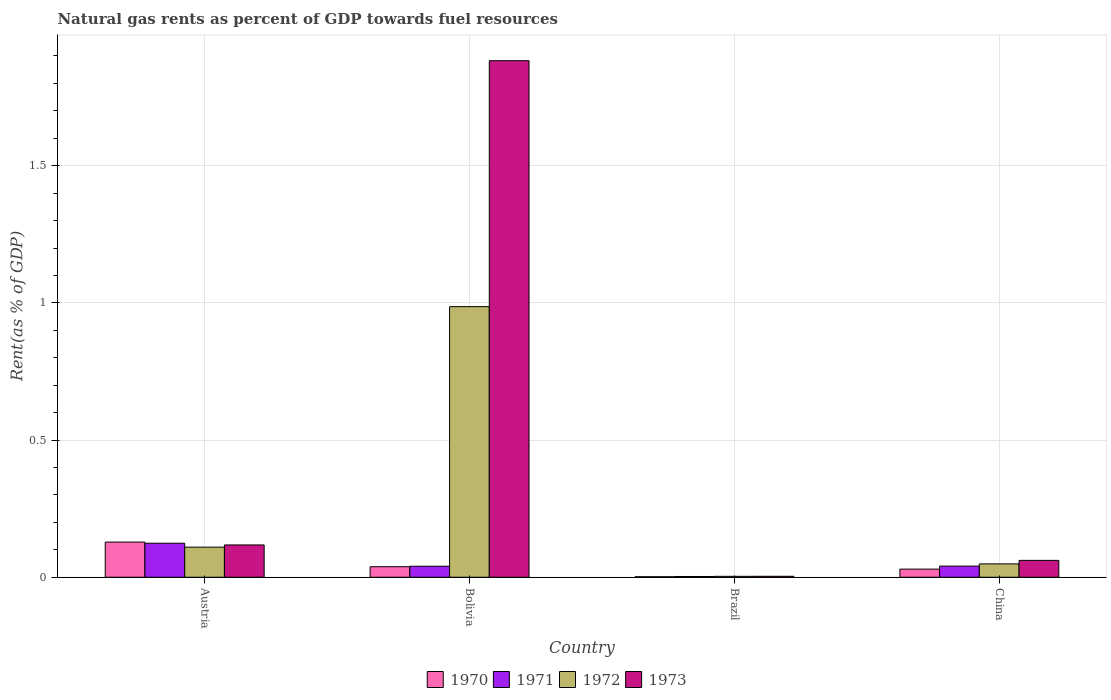How many groups of bars are there?
Make the answer very short. 4. How many bars are there on the 1st tick from the left?
Offer a terse response. 4. What is the label of the 1st group of bars from the left?
Your response must be concise. Austria. In how many cases, is the number of bars for a given country not equal to the number of legend labels?
Your answer should be very brief. 0. What is the matural gas rent in 1970 in Austria?
Offer a very short reply. 0.13. Across all countries, what is the maximum matural gas rent in 1971?
Provide a succinct answer. 0.12. Across all countries, what is the minimum matural gas rent in 1970?
Your answer should be compact. 0. In which country was the matural gas rent in 1971 minimum?
Offer a very short reply. Brazil. What is the total matural gas rent in 1970 in the graph?
Offer a very short reply. 0.2. What is the difference between the matural gas rent in 1973 in Bolivia and that in Brazil?
Your answer should be very brief. 1.88. What is the difference between the matural gas rent in 1971 in Austria and the matural gas rent in 1972 in China?
Offer a very short reply. 0.08. What is the average matural gas rent in 1972 per country?
Your response must be concise. 0.29. What is the difference between the matural gas rent of/in 1970 and matural gas rent of/in 1972 in Austria?
Provide a short and direct response. 0.02. What is the ratio of the matural gas rent in 1971 in Austria to that in Bolivia?
Offer a terse response. 3.09. Is the matural gas rent in 1972 in Brazil less than that in China?
Keep it short and to the point. Yes. What is the difference between the highest and the second highest matural gas rent in 1970?
Your answer should be very brief. 0.1. What is the difference between the highest and the lowest matural gas rent in 1973?
Provide a succinct answer. 1.88. In how many countries, is the matural gas rent in 1972 greater than the average matural gas rent in 1972 taken over all countries?
Ensure brevity in your answer.  1. What does the 3rd bar from the left in Austria represents?
Your answer should be very brief. 1972. What does the 1st bar from the right in China represents?
Provide a short and direct response. 1973. Is it the case that in every country, the sum of the matural gas rent in 1970 and matural gas rent in 1971 is greater than the matural gas rent in 1972?
Offer a terse response. No. How many bars are there?
Provide a short and direct response. 16. What is the difference between two consecutive major ticks on the Y-axis?
Provide a short and direct response. 0.5. Are the values on the major ticks of Y-axis written in scientific E-notation?
Ensure brevity in your answer.  No. Does the graph contain any zero values?
Provide a succinct answer. No. How many legend labels are there?
Your answer should be very brief. 4. What is the title of the graph?
Ensure brevity in your answer.  Natural gas rents as percent of GDP towards fuel resources. Does "2008" appear as one of the legend labels in the graph?
Make the answer very short. No. What is the label or title of the X-axis?
Make the answer very short. Country. What is the label or title of the Y-axis?
Your answer should be very brief. Rent(as % of GDP). What is the Rent(as % of GDP) in 1970 in Austria?
Make the answer very short. 0.13. What is the Rent(as % of GDP) of 1971 in Austria?
Your answer should be compact. 0.12. What is the Rent(as % of GDP) of 1972 in Austria?
Ensure brevity in your answer.  0.11. What is the Rent(as % of GDP) in 1973 in Austria?
Provide a short and direct response. 0.12. What is the Rent(as % of GDP) of 1970 in Bolivia?
Ensure brevity in your answer.  0.04. What is the Rent(as % of GDP) in 1971 in Bolivia?
Your response must be concise. 0.04. What is the Rent(as % of GDP) in 1972 in Bolivia?
Give a very brief answer. 0.99. What is the Rent(as % of GDP) in 1973 in Bolivia?
Provide a short and direct response. 1.88. What is the Rent(as % of GDP) of 1970 in Brazil?
Make the answer very short. 0. What is the Rent(as % of GDP) in 1971 in Brazil?
Make the answer very short. 0. What is the Rent(as % of GDP) in 1972 in Brazil?
Provide a short and direct response. 0. What is the Rent(as % of GDP) of 1973 in Brazil?
Provide a short and direct response. 0. What is the Rent(as % of GDP) of 1970 in China?
Provide a short and direct response. 0.03. What is the Rent(as % of GDP) in 1971 in China?
Offer a very short reply. 0.04. What is the Rent(as % of GDP) of 1972 in China?
Offer a terse response. 0.05. What is the Rent(as % of GDP) of 1973 in China?
Your answer should be compact. 0.06. Across all countries, what is the maximum Rent(as % of GDP) in 1970?
Provide a short and direct response. 0.13. Across all countries, what is the maximum Rent(as % of GDP) in 1971?
Your response must be concise. 0.12. Across all countries, what is the maximum Rent(as % of GDP) of 1972?
Your answer should be compact. 0.99. Across all countries, what is the maximum Rent(as % of GDP) of 1973?
Ensure brevity in your answer.  1.88. Across all countries, what is the minimum Rent(as % of GDP) in 1970?
Make the answer very short. 0. Across all countries, what is the minimum Rent(as % of GDP) of 1971?
Your response must be concise. 0. Across all countries, what is the minimum Rent(as % of GDP) in 1972?
Your answer should be very brief. 0. Across all countries, what is the minimum Rent(as % of GDP) of 1973?
Offer a very short reply. 0. What is the total Rent(as % of GDP) of 1970 in the graph?
Your answer should be very brief. 0.2. What is the total Rent(as % of GDP) of 1971 in the graph?
Offer a very short reply. 0.21. What is the total Rent(as % of GDP) of 1972 in the graph?
Keep it short and to the point. 1.15. What is the total Rent(as % of GDP) of 1973 in the graph?
Offer a very short reply. 2.07. What is the difference between the Rent(as % of GDP) in 1970 in Austria and that in Bolivia?
Offer a very short reply. 0.09. What is the difference between the Rent(as % of GDP) in 1971 in Austria and that in Bolivia?
Ensure brevity in your answer.  0.08. What is the difference between the Rent(as % of GDP) in 1972 in Austria and that in Bolivia?
Ensure brevity in your answer.  -0.88. What is the difference between the Rent(as % of GDP) in 1973 in Austria and that in Bolivia?
Provide a succinct answer. -1.77. What is the difference between the Rent(as % of GDP) of 1970 in Austria and that in Brazil?
Your response must be concise. 0.13. What is the difference between the Rent(as % of GDP) of 1971 in Austria and that in Brazil?
Provide a short and direct response. 0.12. What is the difference between the Rent(as % of GDP) in 1972 in Austria and that in Brazil?
Your response must be concise. 0.11. What is the difference between the Rent(as % of GDP) of 1973 in Austria and that in Brazil?
Make the answer very short. 0.11. What is the difference between the Rent(as % of GDP) in 1970 in Austria and that in China?
Your response must be concise. 0.1. What is the difference between the Rent(as % of GDP) of 1971 in Austria and that in China?
Provide a short and direct response. 0.08. What is the difference between the Rent(as % of GDP) of 1972 in Austria and that in China?
Your answer should be very brief. 0.06. What is the difference between the Rent(as % of GDP) of 1973 in Austria and that in China?
Give a very brief answer. 0.06. What is the difference between the Rent(as % of GDP) in 1970 in Bolivia and that in Brazil?
Keep it short and to the point. 0.04. What is the difference between the Rent(as % of GDP) of 1971 in Bolivia and that in Brazil?
Give a very brief answer. 0.04. What is the difference between the Rent(as % of GDP) in 1972 in Bolivia and that in Brazil?
Offer a terse response. 0.98. What is the difference between the Rent(as % of GDP) of 1973 in Bolivia and that in Brazil?
Provide a short and direct response. 1.88. What is the difference between the Rent(as % of GDP) of 1970 in Bolivia and that in China?
Your answer should be compact. 0.01. What is the difference between the Rent(as % of GDP) in 1971 in Bolivia and that in China?
Provide a short and direct response. -0. What is the difference between the Rent(as % of GDP) in 1972 in Bolivia and that in China?
Your response must be concise. 0.94. What is the difference between the Rent(as % of GDP) of 1973 in Bolivia and that in China?
Give a very brief answer. 1.82. What is the difference between the Rent(as % of GDP) of 1970 in Brazil and that in China?
Make the answer very short. -0.03. What is the difference between the Rent(as % of GDP) of 1971 in Brazil and that in China?
Offer a terse response. -0.04. What is the difference between the Rent(as % of GDP) of 1972 in Brazil and that in China?
Your response must be concise. -0.05. What is the difference between the Rent(as % of GDP) of 1973 in Brazil and that in China?
Ensure brevity in your answer.  -0.06. What is the difference between the Rent(as % of GDP) in 1970 in Austria and the Rent(as % of GDP) in 1971 in Bolivia?
Your response must be concise. 0.09. What is the difference between the Rent(as % of GDP) in 1970 in Austria and the Rent(as % of GDP) in 1972 in Bolivia?
Offer a terse response. -0.86. What is the difference between the Rent(as % of GDP) in 1970 in Austria and the Rent(as % of GDP) in 1973 in Bolivia?
Provide a short and direct response. -1.75. What is the difference between the Rent(as % of GDP) in 1971 in Austria and the Rent(as % of GDP) in 1972 in Bolivia?
Make the answer very short. -0.86. What is the difference between the Rent(as % of GDP) in 1971 in Austria and the Rent(as % of GDP) in 1973 in Bolivia?
Keep it short and to the point. -1.76. What is the difference between the Rent(as % of GDP) in 1972 in Austria and the Rent(as % of GDP) in 1973 in Bolivia?
Your answer should be very brief. -1.77. What is the difference between the Rent(as % of GDP) of 1970 in Austria and the Rent(as % of GDP) of 1971 in Brazil?
Offer a very short reply. 0.13. What is the difference between the Rent(as % of GDP) in 1970 in Austria and the Rent(as % of GDP) in 1972 in Brazil?
Keep it short and to the point. 0.12. What is the difference between the Rent(as % of GDP) in 1970 in Austria and the Rent(as % of GDP) in 1973 in Brazil?
Provide a short and direct response. 0.12. What is the difference between the Rent(as % of GDP) of 1971 in Austria and the Rent(as % of GDP) of 1972 in Brazil?
Give a very brief answer. 0.12. What is the difference between the Rent(as % of GDP) in 1971 in Austria and the Rent(as % of GDP) in 1973 in Brazil?
Your answer should be compact. 0.12. What is the difference between the Rent(as % of GDP) in 1972 in Austria and the Rent(as % of GDP) in 1973 in Brazil?
Offer a terse response. 0.11. What is the difference between the Rent(as % of GDP) of 1970 in Austria and the Rent(as % of GDP) of 1971 in China?
Offer a very short reply. 0.09. What is the difference between the Rent(as % of GDP) of 1970 in Austria and the Rent(as % of GDP) of 1972 in China?
Your answer should be compact. 0.08. What is the difference between the Rent(as % of GDP) of 1970 in Austria and the Rent(as % of GDP) of 1973 in China?
Your answer should be very brief. 0.07. What is the difference between the Rent(as % of GDP) of 1971 in Austria and the Rent(as % of GDP) of 1972 in China?
Provide a short and direct response. 0.08. What is the difference between the Rent(as % of GDP) in 1971 in Austria and the Rent(as % of GDP) in 1973 in China?
Ensure brevity in your answer.  0.06. What is the difference between the Rent(as % of GDP) of 1972 in Austria and the Rent(as % of GDP) of 1973 in China?
Your answer should be compact. 0.05. What is the difference between the Rent(as % of GDP) of 1970 in Bolivia and the Rent(as % of GDP) of 1971 in Brazil?
Give a very brief answer. 0.04. What is the difference between the Rent(as % of GDP) in 1970 in Bolivia and the Rent(as % of GDP) in 1972 in Brazil?
Give a very brief answer. 0.04. What is the difference between the Rent(as % of GDP) of 1970 in Bolivia and the Rent(as % of GDP) of 1973 in Brazil?
Offer a very short reply. 0.03. What is the difference between the Rent(as % of GDP) in 1971 in Bolivia and the Rent(as % of GDP) in 1972 in Brazil?
Keep it short and to the point. 0.04. What is the difference between the Rent(as % of GDP) of 1971 in Bolivia and the Rent(as % of GDP) of 1973 in Brazil?
Your answer should be compact. 0.04. What is the difference between the Rent(as % of GDP) in 1972 in Bolivia and the Rent(as % of GDP) in 1973 in Brazil?
Offer a terse response. 0.98. What is the difference between the Rent(as % of GDP) of 1970 in Bolivia and the Rent(as % of GDP) of 1971 in China?
Your answer should be compact. -0. What is the difference between the Rent(as % of GDP) in 1970 in Bolivia and the Rent(as % of GDP) in 1972 in China?
Your response must be concise. -0.01. What is the difference between the Rent(as % of GDP) in 1970 in Bolivia and the Rent(as % of GDP) in 1973 in China?
Provide a short and direct response. -0.02. What is the difference between the Rent(as % of GDP) of 1971 in Bolivia and the Rent(as % of GDP) of 1972 in China?
Ensure brevity in your answer.  -0.01. What is the difference between the Rent(as % of GDP) of 1971 in Bolivia and the Rent(as % of GDP) of 1973 in China?
Your response must be concise. -0.02. What is the difference between the Rent(as % of GDP) of 1972 in Bolivia and the Rent(as % of GDP) of 1973 in China?
Keep it short and to the point. 0.92. What is the difference between the Rent(as % of GDP) of 1970 in Brazil and the Rent(as % of GDP) of 1971 in China?
Offer a very short reply. -0.04. What is the difference between the Rent(as % of GDP) in 1970 in Brazil and the Rent(as % of GDP) in 1972 in China?
Offer a very short reply. -0.05. What is the difference between the Rent(as % of GDP) in 1970 in Brazil and the Rent(as % of GDP) in 1973 in China?
Give a very brief answer. -0.06. What is the difference between the Rent(as % of GDP) of 1971 in Brazil and the Rent(as % of GDP) of 1972 in China?
Give a very brief answer. -0.05. What is the difference between the Rent(as % of GDP) of 1971 in Brazil and the Rent(as % of GDP) of 1973 in China?
Offer a very short reply. -0.06. What is the difference between the Rent(as % of GDP) of 1972 in Brazil and the Rent(as % of GDP) of 1973 in China?
Give a very brief answer. -0.06. What is the average Rent(as % of GDP) of 1970 per country?
Your answer should be compact. 0.05. What is the average Rent(as % of GDP) in 1971 per country?
Give a very brief answer. 0.05. What is the average Rent(as % of GDP) in 1972 per country?
Make the answer very short. 0.29. What is the average Rent(as % of GDP) in 1973 per country?
Keep it short and to the point. 0.52. What is the difference between the Rent(as % of GDP) in 1970 and Rent(as % of GDP) in 1971 in Austria?
Ensure brevity in your answer.  0. What is the difference between the Rent(as % of GDP) in 1970 and Rent(as % of GDP) in 1972 in Austria?
Make the answer very short. 0.02. What is the difference between the Rent(as % of GDP) of 1970 and Rent(as % of GDP) of 1973 in Austria?
Your answer should be compact. 0.01. What is the difference between the Rent(as % of GDP) of 1971 and Rent(as % of GDP) of 1972 in Austria?
Ensure brevity in your answer.  0.01. What is the difference between the Rent(as % of GDP) of 1971 and Rent(as % of GDP) of 1973 in Austria?
Ensure brevity in your answer.  0.01. What is the difference between the Rent(as % of GDP) in 1972 and Rent(as % of GDP) in 1973 in Austria?
Give a very brief answer. -0.01. What is the difference between the Rent(as % of GDP) of 1970 and Rent(as % of GDP) of 1971 in Bolivia?
Your answer should be very brief. -0. What is the difference between the Rent(as % of GDP) of 1970 and Rent(as % of GDP) of 1972 in Bolivia?
Offer a very short reply. -0.95. What is the difference between the Rent(as % of GDP) in 1970 and Rent(as % of GDP) in 1973 in Bolivia?
Your answer should be very brief. -1.84. What is the difference between the Rent(as % of GDP) in 1971 and Rent(as % of GDP) in 1972 in Bolivia?
Offer a very short reply. -0.95. What is the difference between the Rent(as % of GDP) of 1971 and Rent(as % of GDP) of 1973 in Bolivia?
Your answer should be compact. -1.84. What is the difference between the Rent(as % of GDP) in 1972 and Rent(as % of GDP) in 1973 in Bolivia?
Offer a terse response. -0.9. What is the difference between the Rent(as % of GDP) in 1970 and Rent(as % of GDP) in 1971 in Brazil?
Offer a very short reply. -0. What is the difference between the Rent(as % of GDP) in 1970 and Rent(as % of GDP) in 1972 in Brazil?
Your answer should be compact. -0. What is the difference between the Rent(as % of GDP) of 1970 and Rent(as % of GDP) of 1973 in Brazil?
Offer a very short reply. -0. What is the difference between the Rent(as % of GDP) in 1971 and Rent(as % of GDP) in 1972 in Brazil?
Ensure brevity in your answer.  -0. What is the difference between the Rent(as % of GDP) of 1971 and Rent(as % of GDP) of 1973 in Brazil?
Provide a succinct answer. -0. What is the difference between the Rent(as % of GDP) in 1972 and Rent(as % of GDP) in 1973 in Brazil?
Provide a succinct answer. -0. What is the difference between the Rent(as % of GDP) in 1970 and Rent(as % of GDP) in 1971 in China?
Give a very brief answer. -0.01. What is the difference between the Rent(as % of GDP) in 1970 and Rent(as % of GDP) in 1972 in China?
Your response must be concise. -0.02. What is the difference between the Rent(as % of GDP) in 1970 and Rent(as % of GDP) in 1973 in China?
Provide a succinct answer. -0.03. What is the difference between the Rent(as % of GDP) in 1971 and Rent(as % of GDP) in 1972 in China?
Keep it short and to the point. -0.01. What is the difference between the Rent(as % of GDP) of 1971 and Rent(as % of GDP) of 1973 in China?
Provide a succinct answer. -0.02. What is the difference between the Rent(as % of GDP) in 1972 and Rent(as % of GDP) in 1973 in China?
Ensure brevity in your answer.  -0.01. What is the ratio of the Rent(as % of GDP) of 1970 in Austria to that in Bolivia?
Offer a terse response. 3.34. What is the ratio of the Rent(as % of GDP) of 1971 in Austria to that in Bolivia?
Provide a short and direct response. 3.09. What is the ratio of the Rent(as % of GDP) of 1972 in Austria to that in Bolivia?
Provide a short and direct response. 0.11. What is the ratio of the Rent(as % of GDP) of 1973 in Austria to that in Bolivia?
Offer a terse response. 0.06. What is the ratio of the Rent(as % of GDP) of 1970 in Austria to that in Brazil?
Make the answer very short. 72. What is the ratio of the Rent(as % of GDP) in 1971 in Austria to that in Brazil?
Offer a very short reply. 45.2. What is the ratio of the Rent(as % of GDP) of 1972 in Austria to that in Brazil?
Ensure brevity in your answer.  33.07. What is the ratio of the Rent(as % of GDP) in 1973 in Austria to that in Brazil?
Provide a short and direct response. 33.74. What is the ratio of the Rent(as % of GDP) of 1970 in Austria to that in China?
Your answer should be very brief. 4.32. What is the ratio of the Rent(as % of GDP) of 1971 in Austria to that in China?
Give a very brief answer. 3.06. What is the ratio of the Rent(as % of GDP) in 1972 in Austria to that in China?
Your answer should be compact. 2.25. What is the ratio of the Rent(as % of GDP) of 1973 in Austria to that in China?
Offer a terse response. 1.92. What is the ratio of the Rent(as % of GDP) of 1970 in Bolivia to that in Brazil?
Your response must be concise. 21.58. What is the ratio of the Rent(as % of GDP) of 1971 in Bolivia to that in Brazil?
Your response must be concise. 14.62. What is the ratio of the Rent(as % of GDP) of 1972 in Bolivia to that in Brazil?
Your answer should be very brief. 297.41. What is the ratio of the Rent(as % of GDP) in 1973 in Bolivia to that in Brazil?
Ensure brevity in your answer.  539.46. What is the ratio of the Rent(as % of GDP) in 1970 in Bolivia to that in China?
Ensure brevity in your answer.  1.3. What is the ratio of the Rent(as % of GDP) in 1971 in Bolivia to that in China?
Give a very brief answer. 0.99. What is the ratio of the Rent(as % of GDP) of 1972 in Bolivia to that in China?
Make the answer very short. 20.28. What is the ratio of the Rent(as % of GDP) of 1973 in Bolivia to that in China?
Keep it short and to the point. 30.65. What is the ratio of the Rent(as % of GDP) of 1971 in Brazil to that in China?
Ensure brevity in your answer.  0.07. What is the ratio of the Rent(as % of GDP) in 1972 in Brazil to that in China?
Provide a succinct answer. 0.07. What is the ratio of the Rent(as % of GDP) of 1973 in Brazil to that in China?
Offer a terse response. 0.06. What is the difference between the highest and the second highest Rent(as % of GDP) in 1970?
Provide a short and direct response. 0.09. What is the difference between the highest and the second highest Rent(as % of GDP) of 1971?
Offer a very short reply. 0.08. What is the difference between the highest and the second highest Rent(as % of GDP) in 1972?
Make the answer very short. 0.88. What is the difference between the highest and the second highest Rent(as % of GDP) in 1973?
Your response must be concise. 1.77. What is the difference between the highest and the lowest Rent(as % of GDP) in 1970?
Give a very brief answer. 0.13. What is the difference between the highest and the lowest Rent(as % of GDP) in 1971?
Ensure brevity in your answer.  0.12. What is the difference between the highest and the lowest Rent(as % of GDP) of 1972?
Provide a short and direct response. 0.98. What is the difference between the highest and the lowest Rent(as % of GDP) of 1973?
Your answer should be compact. 1.88. 